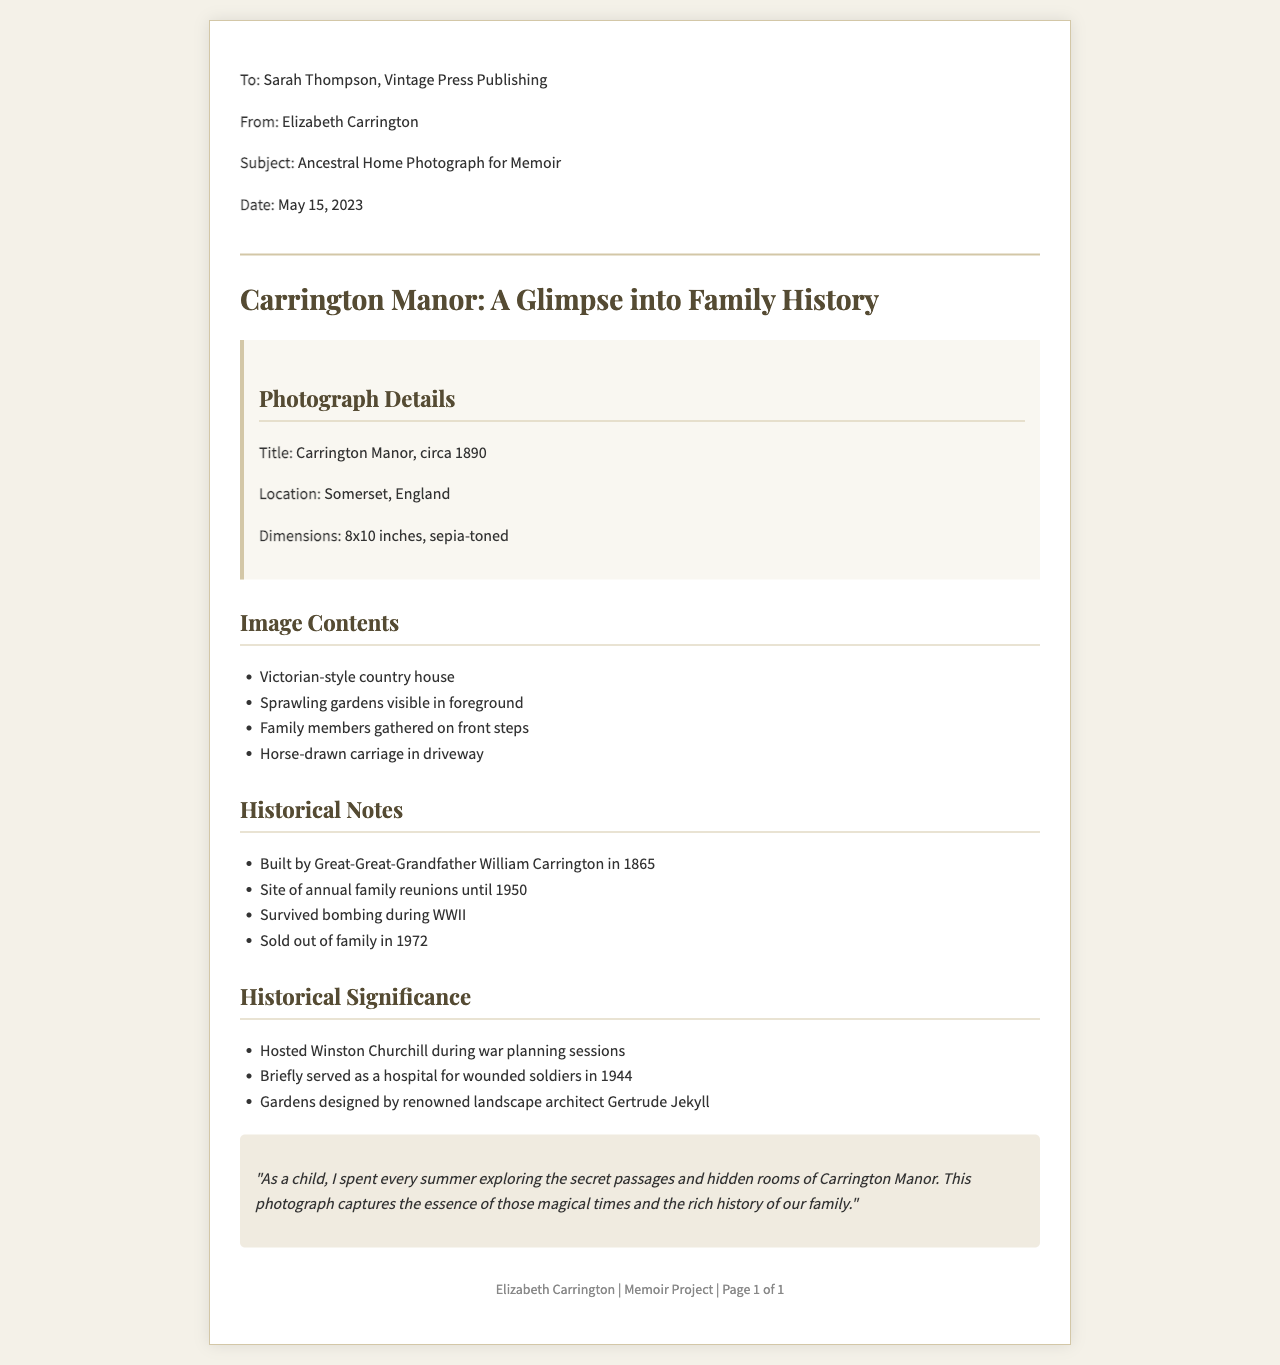What is the title of the photograph? The title is provided in the "Photograph Details" section of the document, which states "Carrington Manor, circa 1890."
Answer: Carrington Manor, circa 1890 Where is Carrington Manor located? The location of Carrington Manor is mentioned in the "Photograph Details" section, specifically stating "Somerset, England."
Answer: Somerset, England When was Carrington Manor built? The date is referenced in the "Historical Notes," indicating it was built in "1865."
Answer: 1865 Who is the author of the fax? The author's name can be found at the top of the document in the “From” section as "Elizabeth Carrington."
Answer: Elizabeth Carrington What significant event took place at Carrington Manor during World War II? The "Historical Significance" section provides information that states it "served as a hospital for wounded soldiers in 1944."
Answer: served as a hospital for wounded soldiers in 1944 Which family member built Carrington Manor? The document specifies that "Great-Great-Grandfather William Carrington" built the manor, as indicated in the "Historical Notes."
Answer: Great-Great-Grandfather William Carrington What is one use of the gardens mentioned in the document? The "Historical Significance" section mentions the gardens were designed by "renowned landscape architect Gertrude Jekyll."
Answer: renowned landscape architect Gertrude Jekyll What type of document is this? The format and heading reveal that this is a fax sent regarding a photograph for a memoir project.
Answer: Fax What year was Carrington Manor sold out of the family? The document states that Carrington Manor was sold in "1972," which is part of the historical notes.
Answer: 1972 